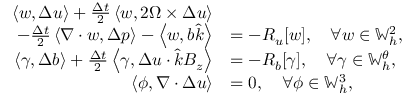Convert formula to latex. <formula><loc_0><loc_0><loc_500><loc_500>\begin{array} { r l } { \left \langle w , \Delta u \right \rangle + \frac { \Delta t } { 2 } \left \langle w , 2 \Omega \times \Delta u \right \rangle } \\ { \quad - \frac { \Delta t } { 2 } \left \langle \nabla \cdot w , \Delta p \right \rangle - \left \langle w , b \hat { k } \right \rangle } & { = - R _ { u } [ w ] , \quad \forall w \in \mathbb { W } _ { h } ^ { 2 } , } \\ { \left \langle \gamma , \Delta b \right \rangle + \frac { \Delta t } { 2 } \left \langle \gamma , \Delta u \cdot \hat { k } B _ { z } \right \rangle } & { = - R _ { b } [ \gamma ] , \quad \forall \gamma \in \mathbb { W } _ { h } ^ { \theta } , } \\ { \left \langle \phi , \nabla \cdot \Delta u \right \rangle } & { = 0 , \quad \forall \phi \in \mathbb { W } _ { h } ^ { 3 } , } \end{array}</formula> 